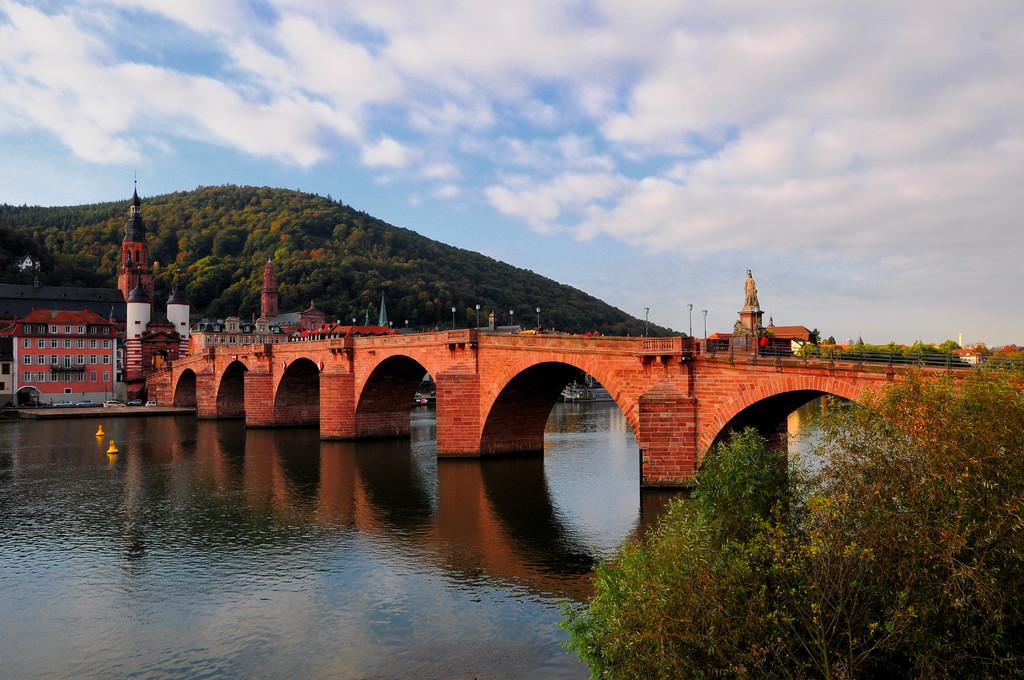What is the main feature of the image? The main features of the image are water, a bridge, a statue, a hill, buildings, vehicles, trees, plants, and the sky. Can you describe the bridge in the image? The bridge is a structure that connects two sides of the water in the image. What is the statue in the image depicting? The statue in the image is a sculpture of a person or object, but its specific subject is not mentioned in the facts. What type of structures can be seen in the image? Buildings are visible in the image. What type of transportation is present in the image? Vehicles are present in the image. What type of vegetation can be seen in the image? Trees and plants are visible in the image. What is visible in the background of the image? The sky is visible in the background of the image. How many people are in the crowd gathered around the statue in the image? There is no crowd present in the image; it only shows a statue, a bridge, water, a hill, buildings, vehicles, trees, plants, and the sky. 